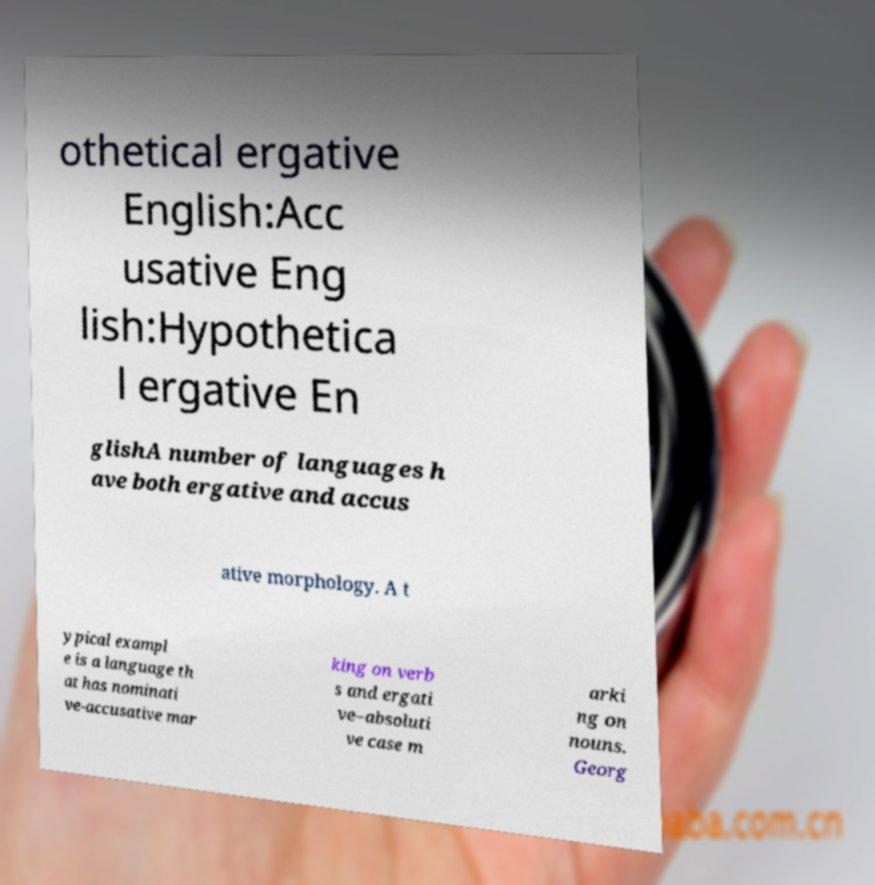Could you extract and type out the text from this image? othetical ergative English:Acc usative Eng lish:Hypothetica l ergative En glishA number of languages h ave both ergative and accus ative morphology. A t ypical exampl e is a language th at has nominati ve-accusative mar king on verb s and ergati ve–absoluti ve case m arki ng on nouns. Georg 